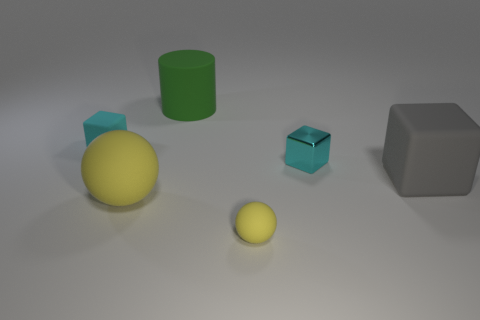How many cyan blocks must be subtracted to get 1 cyan blocks? 1 Add 3 big blue shiny cylinders. How many objects exist? 9 Subtract all small matte cubes. How many cubes are left? 2 Subtract all balls. How many objects are left? 4 Subtract 2 cubes. How many cubes are left? 1 Subtract all cyan spheres. Subtract all red cubes. How many spheres are left? 2 Subtract all gray spheres. How many brown cylinders are left? 0 Subtract all green objects. Subtract all big yellow things. How many objects are left? 4 Add 2 large yellow balls. How many large yellow balls are left? 3 Add 5 metallic things. How many metallic things exist? 6 